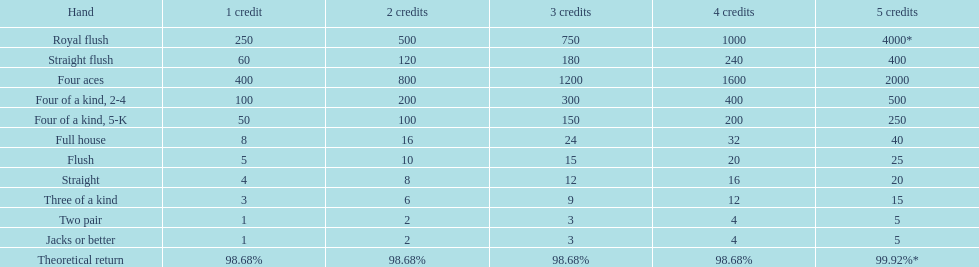Could you help me parse every detail presented in this table? {'header': ['Hand', '1 credit', '2 credits', '3 credits', '4 credits', '5 credits'], 'rows': [['Royal flush', '250', '500', '750', '1000', '4000*'], ['Straight flush', '60', '120', '180', '240', '400'], ['Four aces', '400', '800', '1200', '1600', '2000'], ['Four of a kind, 2-4', '100', '200', '300', '400', '500'], ['Four of a kind, 5-K', '50', '100', '150', '200', '250'], ['Full house', '8', '16', '24', '32', '40'], ['Flush', '5', '10', '15', '20', '25'], ['Straight', '4', '8', '12', '16', '20'], ['Three of a kind', '3', '6', '9', '12', '15'], ['Two pair', '1', '2', '3', '4', '5'], ['Jacks or better', '1', '2', '3', '4', '5'], ['Theoretical return', '98.68%', '98.68%', '98.68%', '98.68%', '99.92%*']]} Every four aces victory is a multiple of which number? 400. 